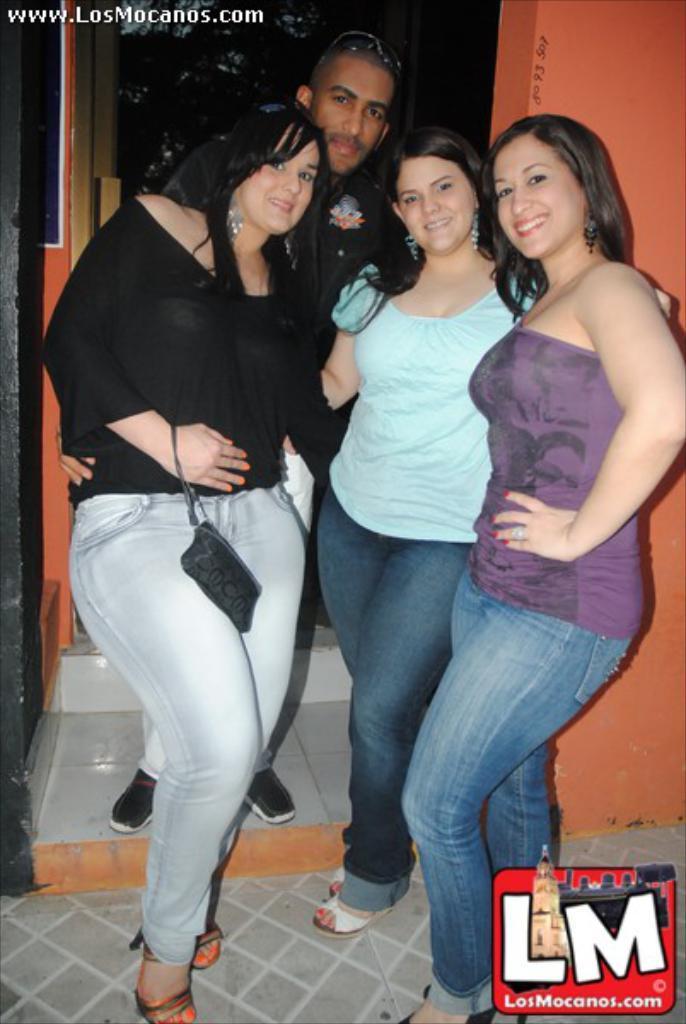In one or two sentences, can you explain what this image depicts? In this image I can see a group of people. On the right side, I can see the wall. 